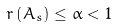<formula> <loc_0><loc_0><loc_500><loc_500>r \left ( A _ { s } \right ) \leq \alpha < 1</formula> 